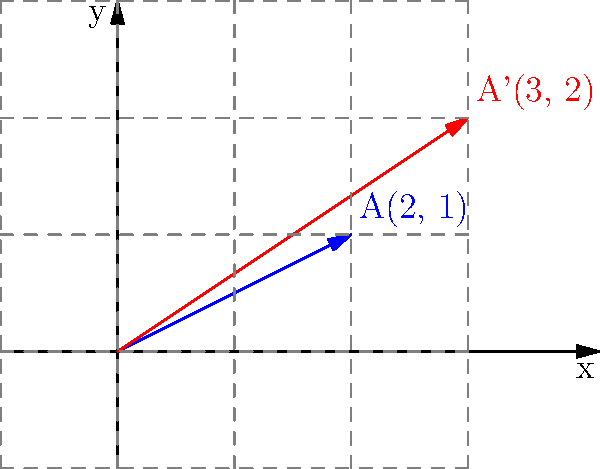A consumer advocacy group has represented product features as a vector A(2, 1). After analyzing consumer feedback, they demand improvements that transform this vector to A'(3, 2). What transformation matrix T would achieve this change when applied to the original vector? To find the transformation matrix T, we need to solve the equation:

$$T \begin{pmatrix} 2 \\ 1 \end{pmatrix} = \begin{pmatrix} 3 \\ 2 \end{pmatrix}$$

Let's assume T is a 2x2 matrix:

$$T = \begin{pmatrix} a & b \\ c & d \end{pmatrix}$$

Step 1: Set up the equation:
$$\begin{pmatrix} a & b \\ c & d \end{pmatrix} \begin{pmatrix} 2 \\ 1 \end{pmatrix} = \begin{pmatrix} 3 \\ 2 \end{pmatrix}$$

Step 2: Multiply the matrices:
$$\begin{pmatrix} 2a + b \\ 2c + d \end{pmatrix} = \begin{pmatrix} 3 \\ 2 \end{pmatrix}$$

Step 3: Set up a system of equations:
$$2a + b = 3$$
$$2c + d = 2$$

Step 4: Solve for a, b, c, and d:
From the first equation: $b = 3 - 2a$
From the second equation: $d = 2 - 2c$

We need two more equations to solve for all variables. We can use the fact that T should work for any point, including (0, 1):

$$T \begin{pmatrix} 0 \\ 1 \end{pmatrix} = \begin{pmatrix} 1 \\ 1 \end{pmatrix}$$

This gives us:
$$b = 1$$
$$d = 1$$

Step 5: Substitute these values back into our original equations:
$$2a + 1 = 3$$
$$2c + 1 = 2$$

Solving these:
$$a = 1$$
$$c = \frac{1}{2}$$

Therefore, the transformation matrix T is:

$$T = \begin{pmatrix} 1 & 1 \\ \frac{1}{2} & 1 \end{pmatrix}$$
Answer: $$\begin{pmatrix} 1 & 1 \\ \frac{1}{2} & 1 \end{pmatrix}$$ 